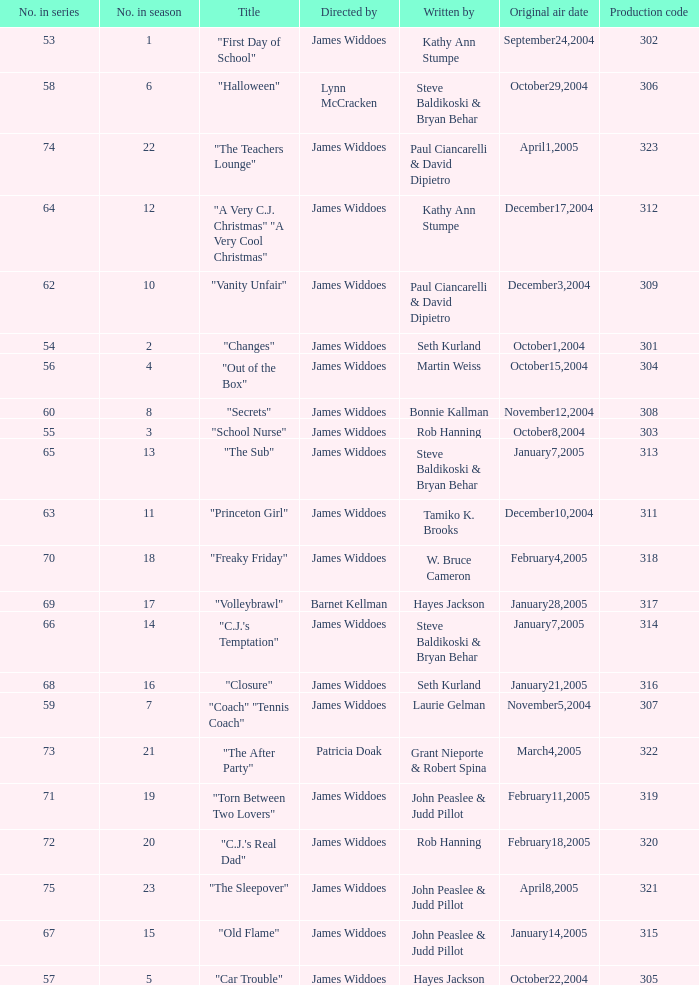What date was the episode originally aired that was directed by James Widdoes and the production code is 320? February18,2005. 